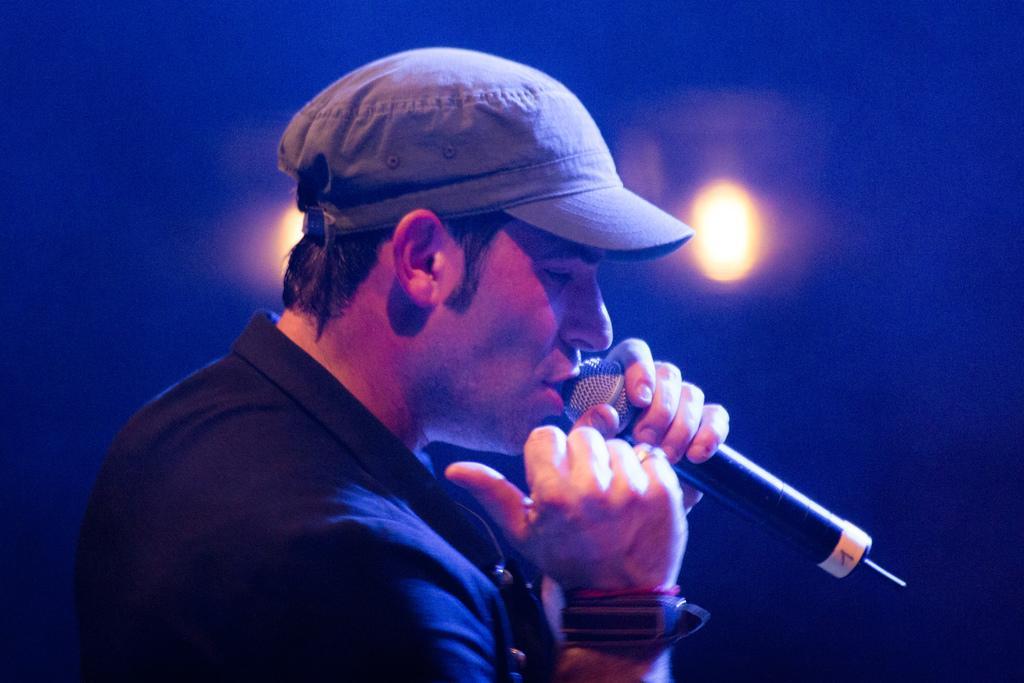Can you describe this image briefly? In this image we can see a person wearing black color dress, cap and also wearing some wristbands holding a microphone in his hands and in the background of the image there are some lights. 